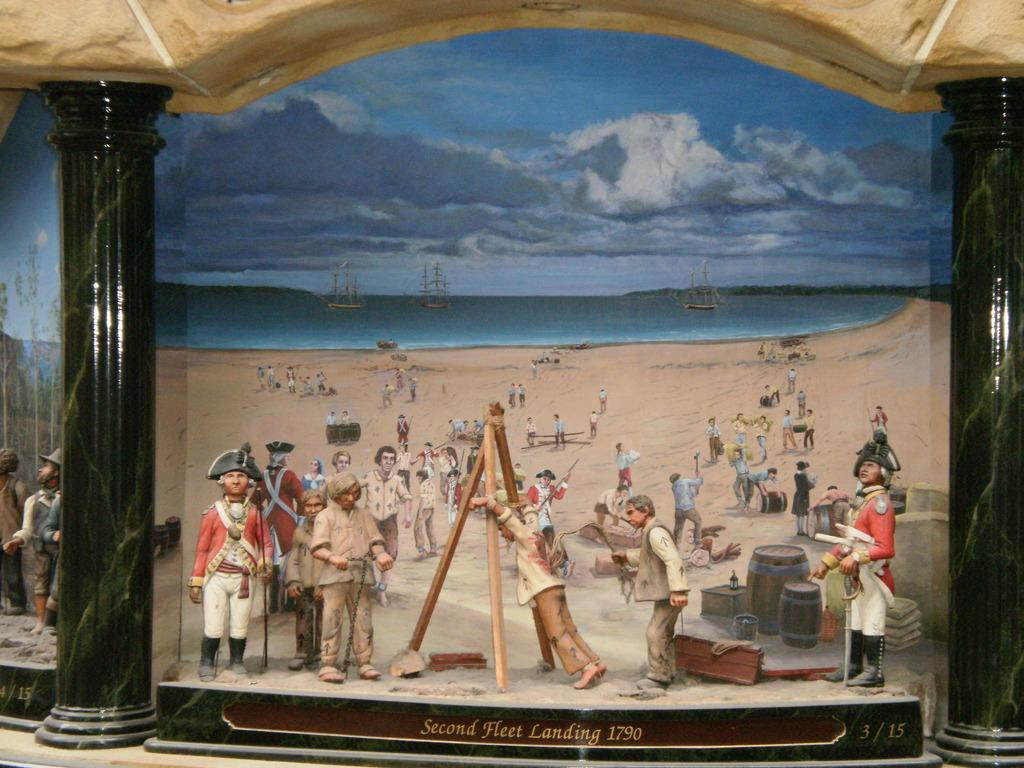<image>
Give a short and clear explanation of the subsequent image. A group of people at a beach with the words "Second Fleet Landing" under them. 